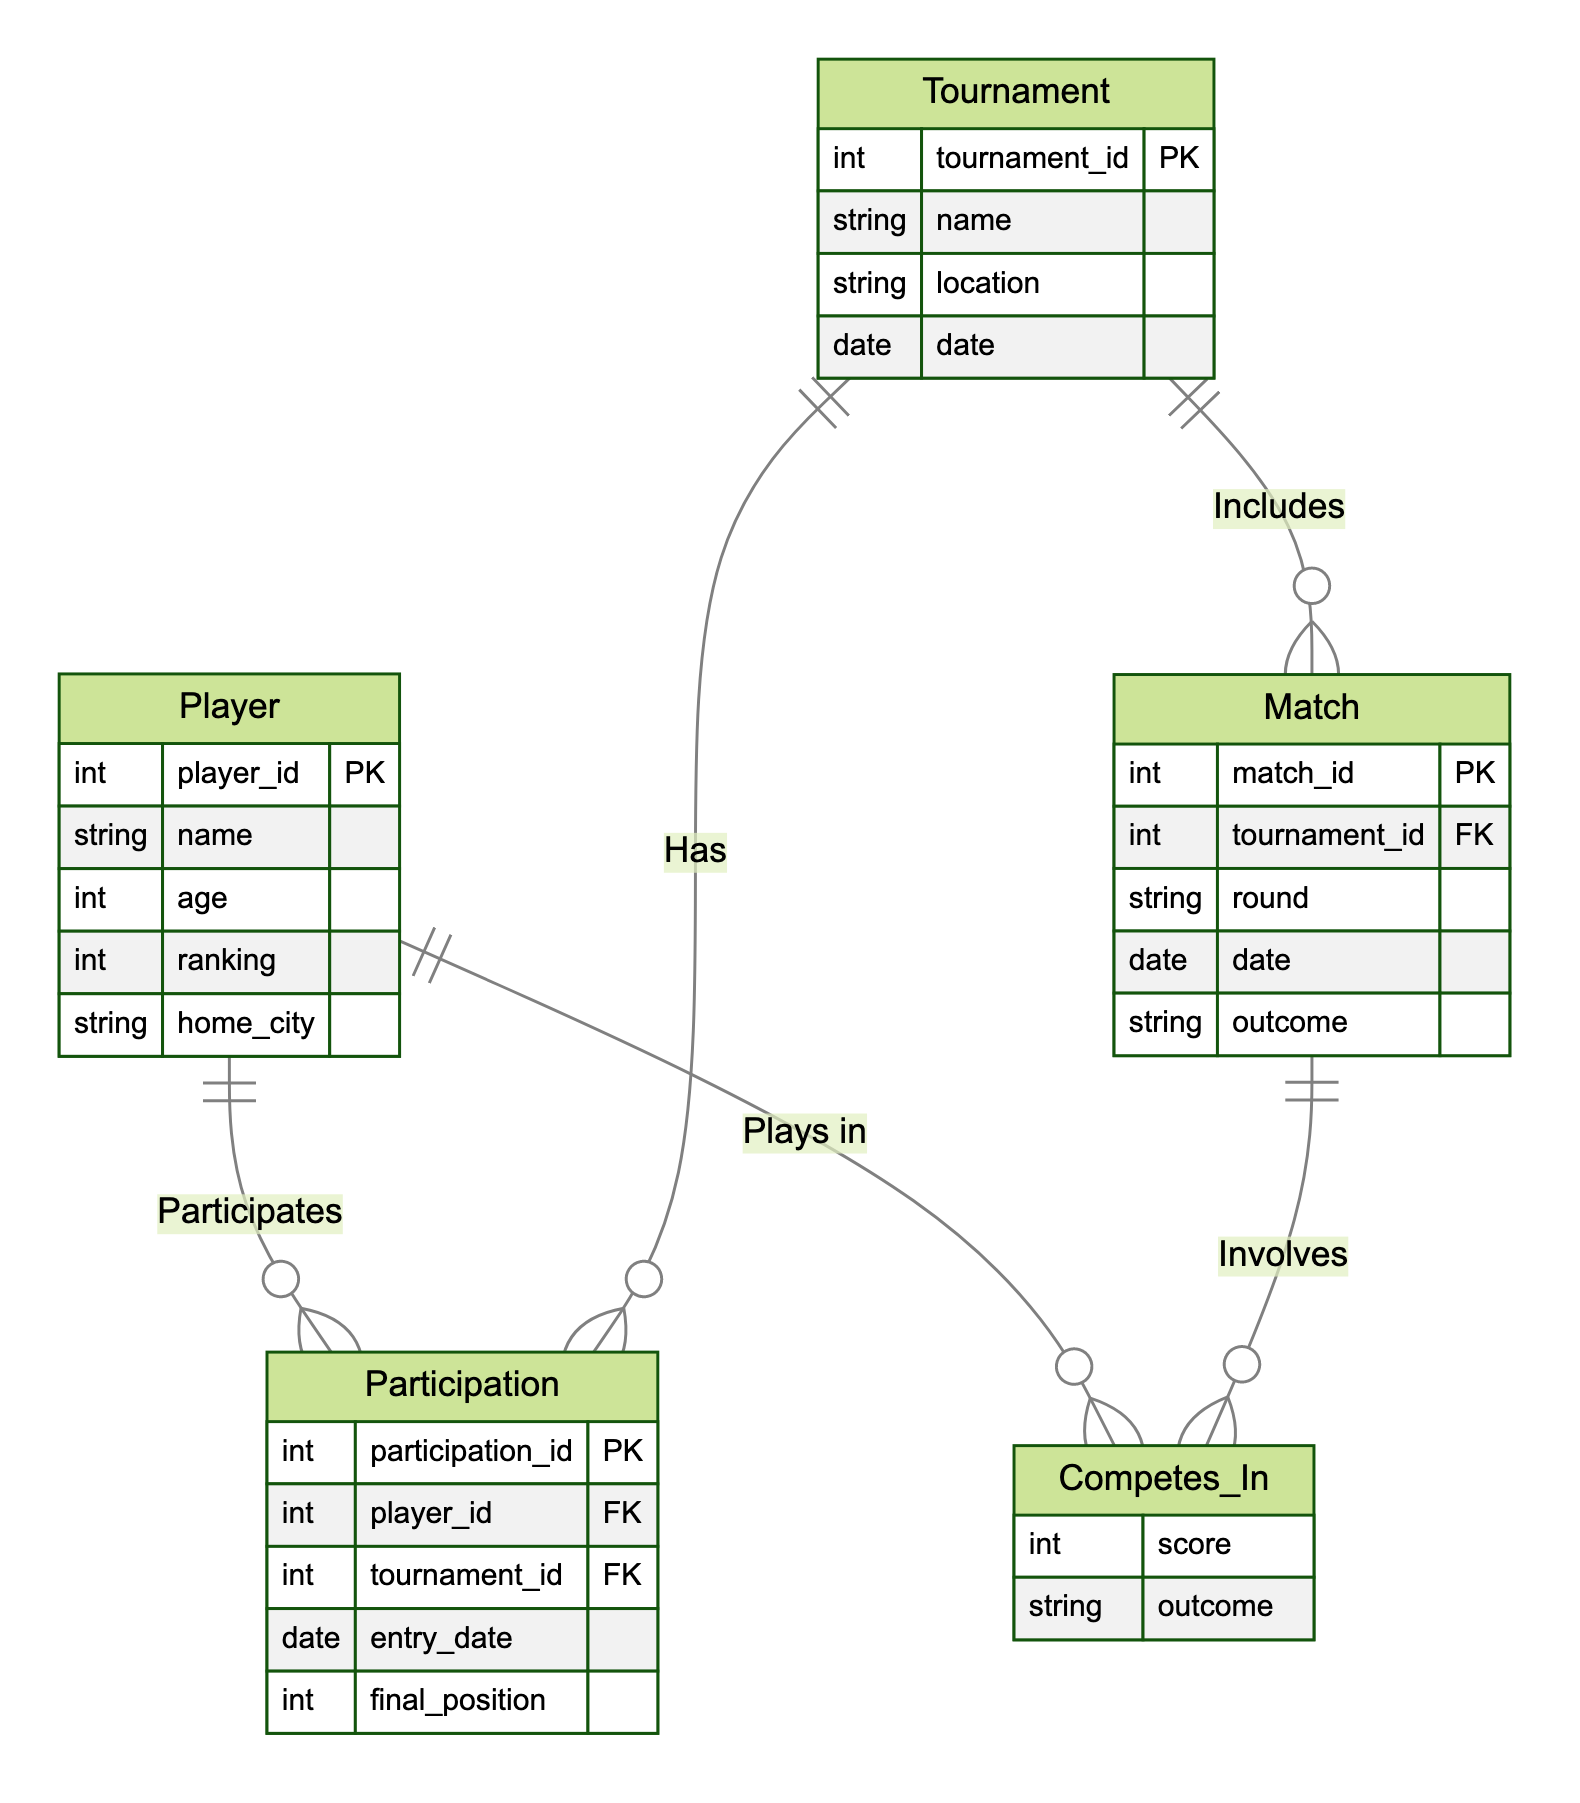What entities are present in the diagram? The diagram includes four entities: Player, Tournament, Match, and Participation.
Answer: Player, Tournament, Match, Participation How many relationships are depicted in the diagram? The diagram shows four relationships: Participates, Competes_In, and Includes.
Answer: Four What is the primary key of the Player entity? The primary key of the Player entity is player_id, which uniquely identifies each player.
Answer: player_id Which entity includes the match details? The Match entity contains the details such as match_id, tournament_id, round, date, and outcome.
Answer: Match What relationship connects Player and Tournament entities? The relationship that connects Player and Tournament entities is called Participates.
Answer: Participates How is the match outcome recorded in the diagram? The outcome of a match is recorded under the attributes of the Match entity as "outcome".
Answer: outcome What does the Participation entity track? The Participation entity tracks the participation of players in tournaments, including entry date and final position.
Answer: Participation of players in tournaments How are matches linked to tournaments? Matches are linked to tournaments through the Includes relationship, indicating that a tournament consists of multiple matches.
Answer: Includes Which entity contains the player's score in a match? The score of a player in a match is contained within the Competes_In relationship attributes, specifically "score".
Answer: score 